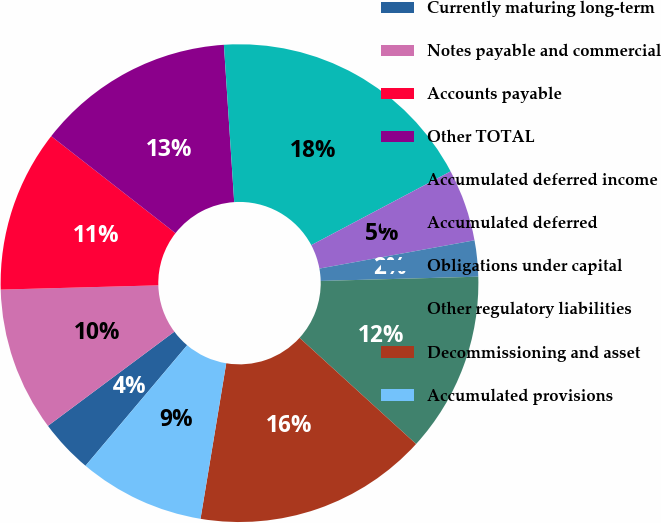<chart> <loc_0><loc_0><loc_500><loc_500><pie_chart><fcel>Currently maturing long-term<fcel>Notes payable and commercial<fcel>Accounts payable<fcel>Other TOTAL<fcel>Accumulated deferred income<fcel>Accumulated deferred<fcel>Obligations under capital<fcel>Other regulatory liabilities<fcel>Decommissioning and asset<fcel>Accumulated provisions<nl><fcel>3.66%<fcel>9.76%<fcel>10.98%<fcel>13.41%<fcel>18.29%<fcel>4.88%<fcel>2.44%<fcel>12.19%<fcel>15.85%<fcel>8.54%<nl></chart> 